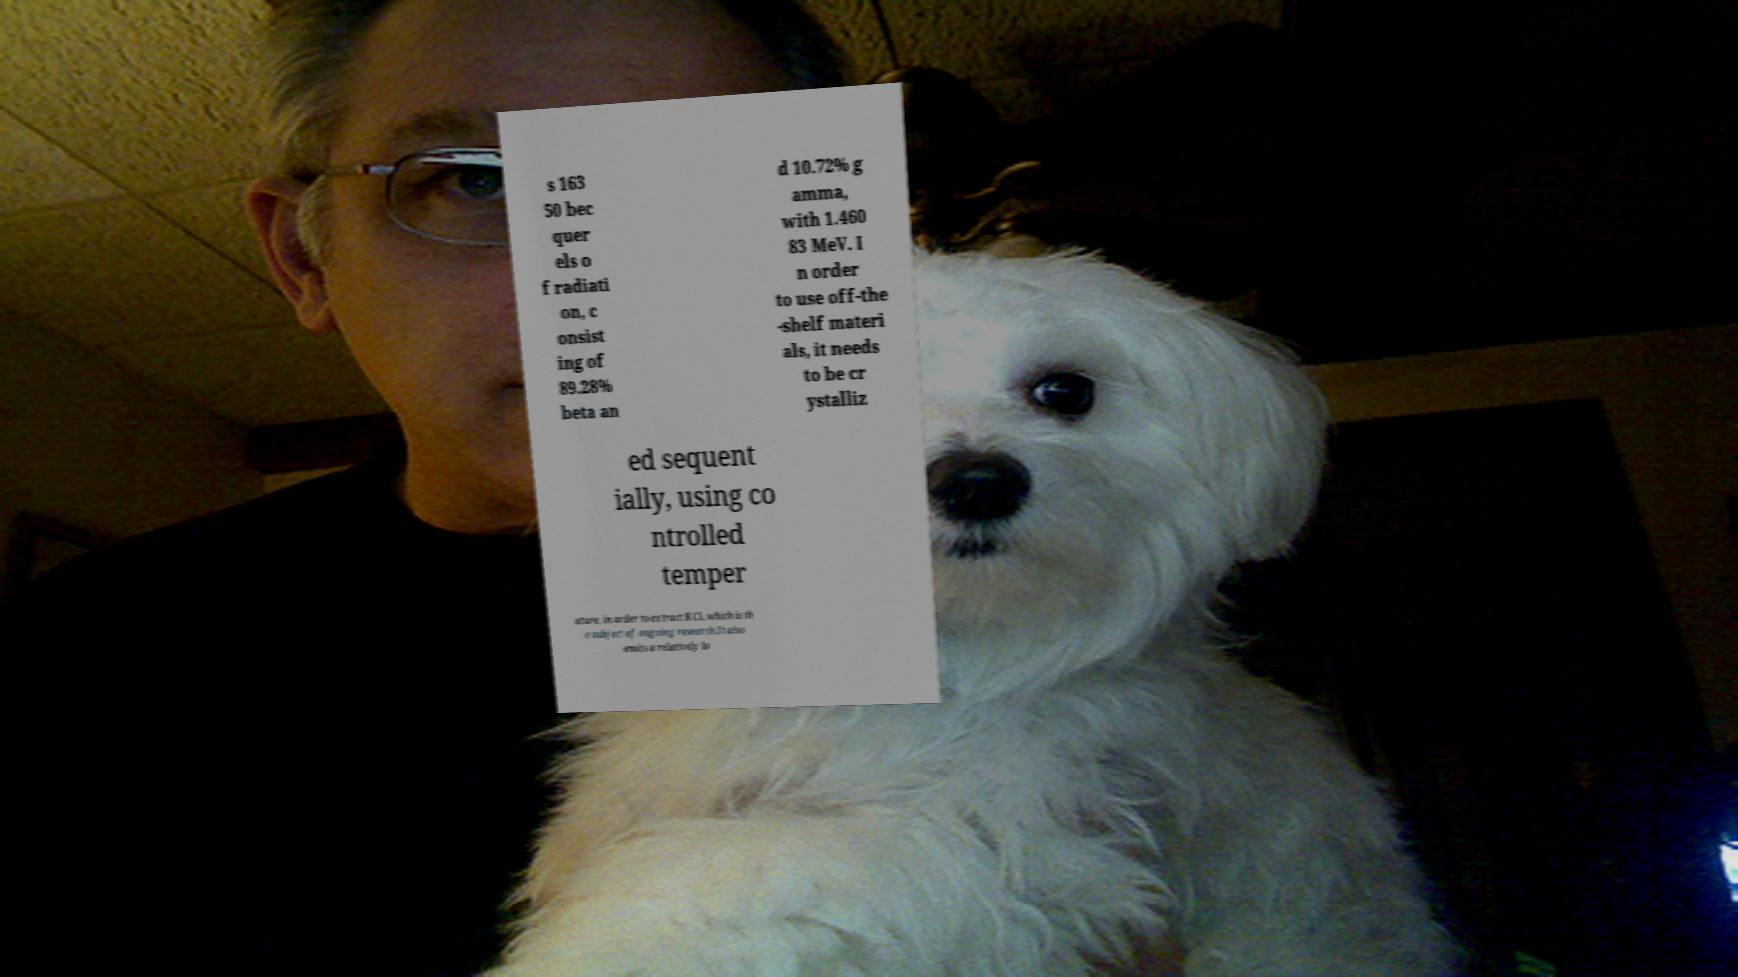What messages or text are displayed in this image? I need them in a readable, typed format. s 163 50 bec quer els o f radiati on, c onsist ing of 89.28% beta an d 10.72% g amma, with 1.460 83 MeV. I n order to use off-the -shelf materi als, it needs to be cr ystalliz ed sequent ially, using co ntrolled temper ature, in order to extract KCl, which is th e subject of ongoing research.It also emits a relatively lo 